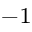Convert formula to latex. <formula><loc_0><loc_0><loc_500><loc_500>^ { - 1 }</formula> 